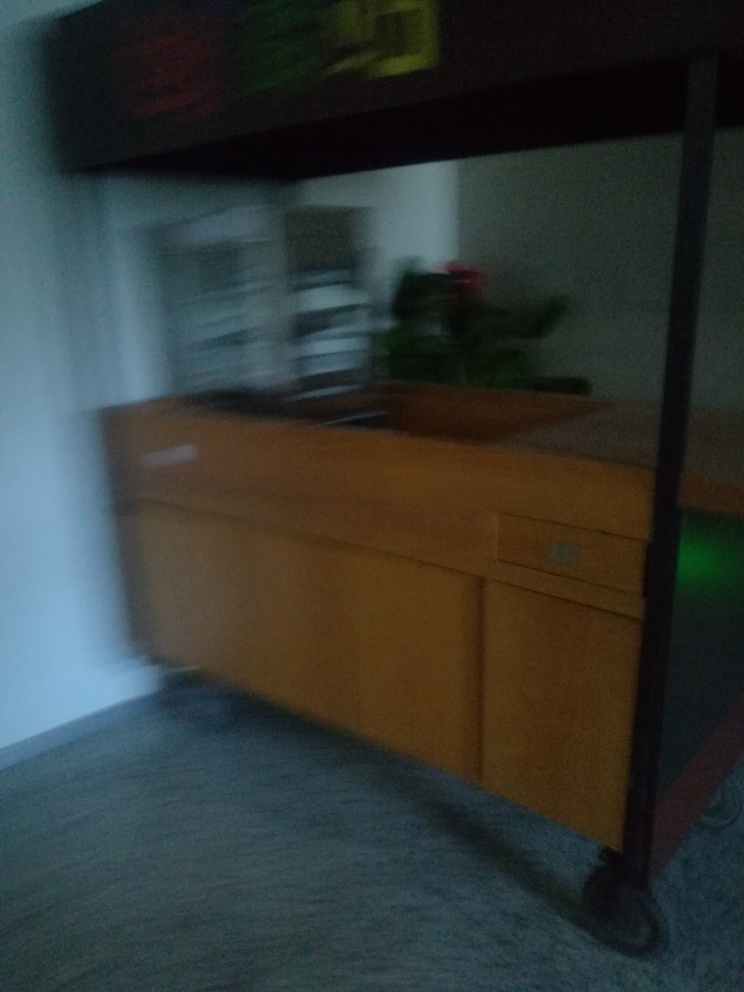What could be a potential subject in this image if the motion blur was not present? Without the motion blur, the subject appears to be an interior space, likely a room with a desk or a counter. The objects are not distinctly clear, but it looks like there might be items on top of the desk and perhaps a plant, suggesting this could be an office or a workspace. 